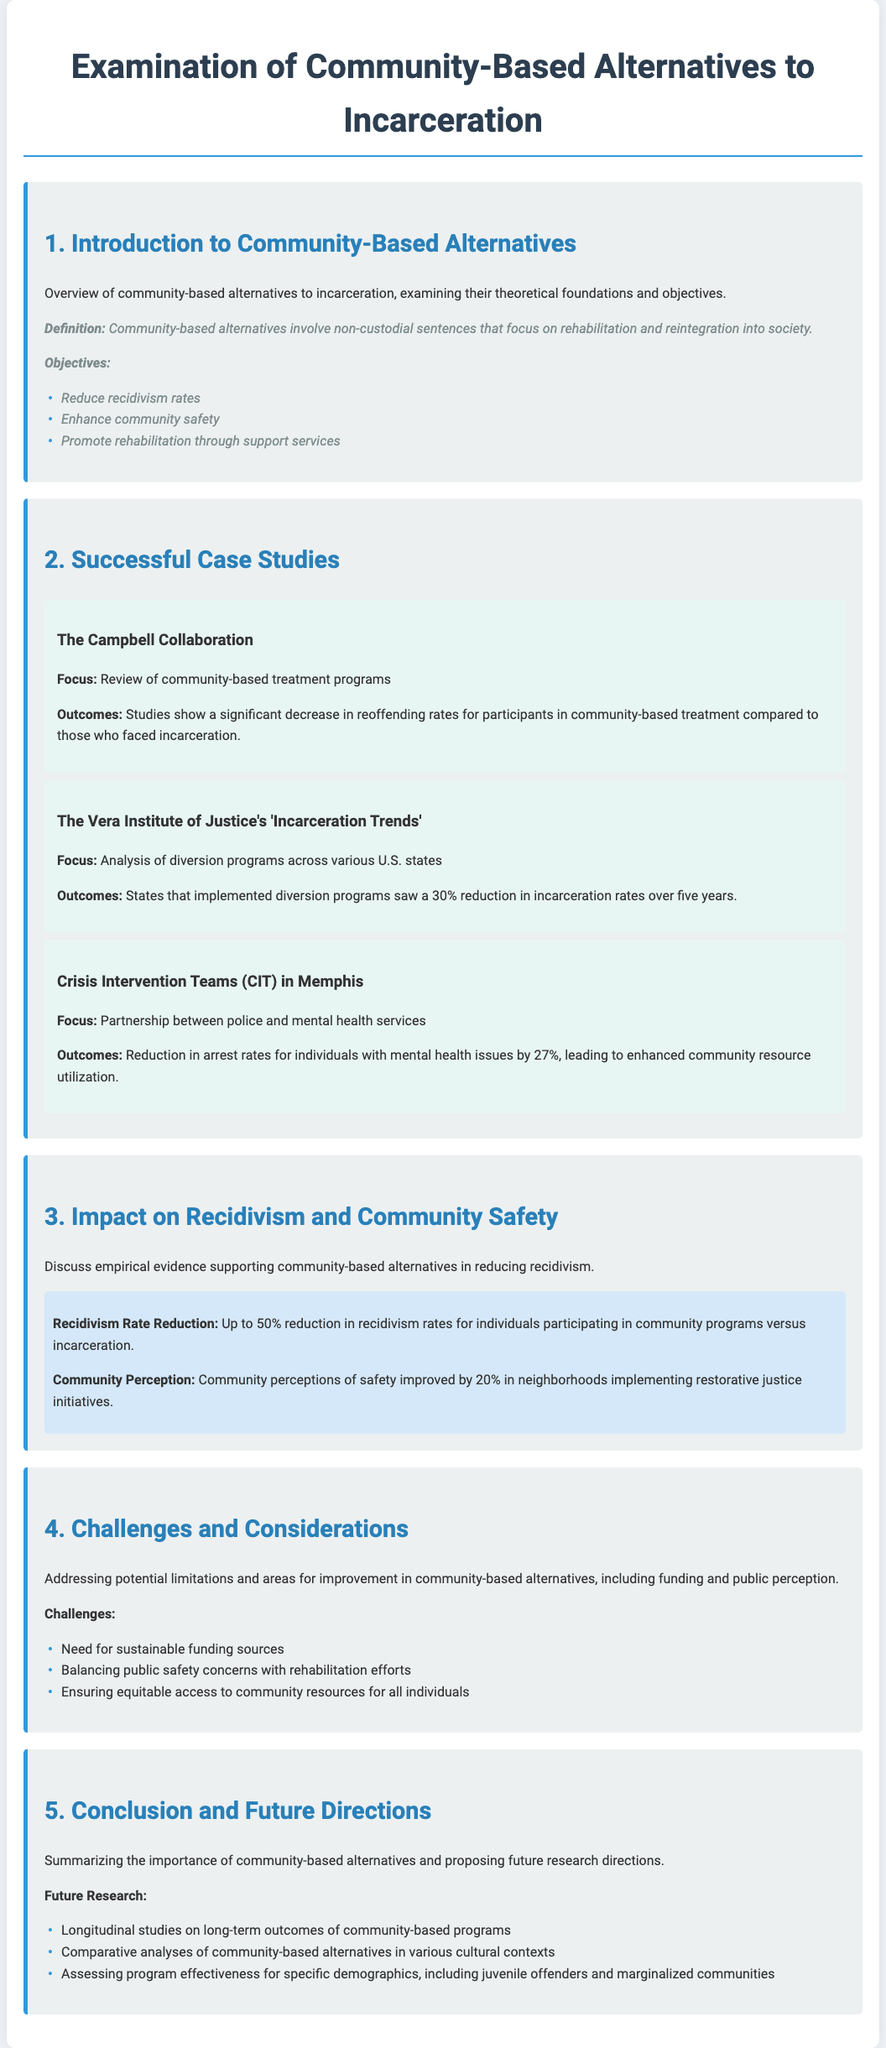What is the main objective of community-based alternatives? The objective of community-based alternatives focuses on reducing recidivism rates, enhancing community safety, and promoting rehabilitation through support services.
Answer: Reduce recidivism rates, enhance community safety, promote rehabilitation Which study focused on community-based treatment programs? The document refers to a specific study by the Campbell Collaboration that reviewed community-based treatment programs.
Answer: The Campbell Collaboration What percentage reduction in incarceration rates was observed by states with diversion programs? The Vera Institute of Justice found that states implementing diversion programs saw a 30% reduction in incarceration rates over five years.
Answer: 30% What was the reduction in arrest rates for individuals with mental health issues in Memphis? The implementation of Crisis Intervention Teams in Memphis led to a 27% reduction in arrest rates for individuals with mental health issues.
Answer: 27% What is a significant challenge mentioned for community-based alternatives? The document lists the need for sustainable funding sources as one of the significant challenges faced by community-based alternatives.
Answer: Sustainable funding sources What is one proposed future research direction regarding community-based programs? The document suggests conducting longitudinal studies on long-term outcomes as one of the future research directions.
Answer: Longitudinal studies on long-term outcomes 